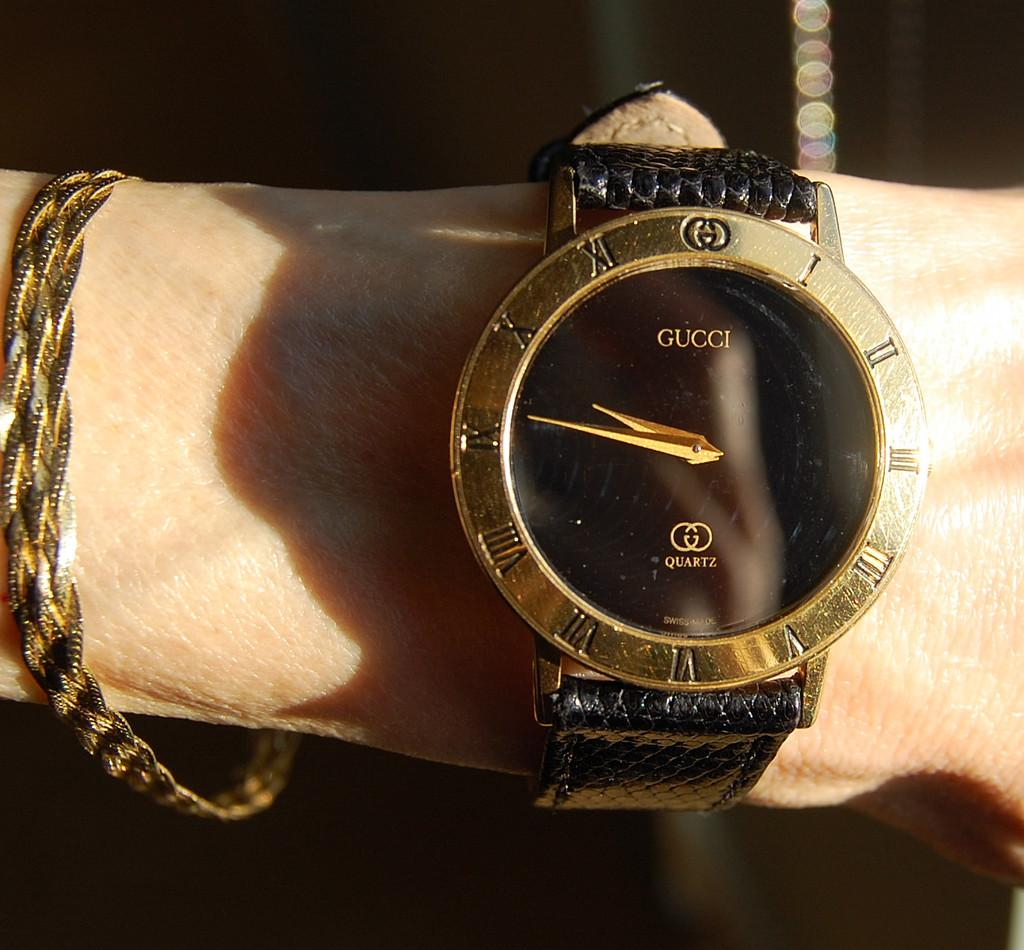<image>
Give a short and clear explanation of the subsequent image. A person is wearing a gold and black Gucci wristwatch. 